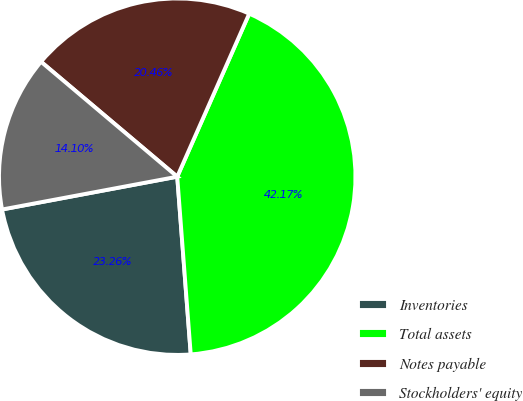<chart> <loc_0><loc_0><loc_500><loc_500><pie_chart><fcel>Inventories<fcel>Total assets<fcel>Notes payable<fcel>Stockholders' equity<nl><fcel>23.26%<fcel>42.17%<fcel>20.46%<fcel>14.1%<nl></chart> 